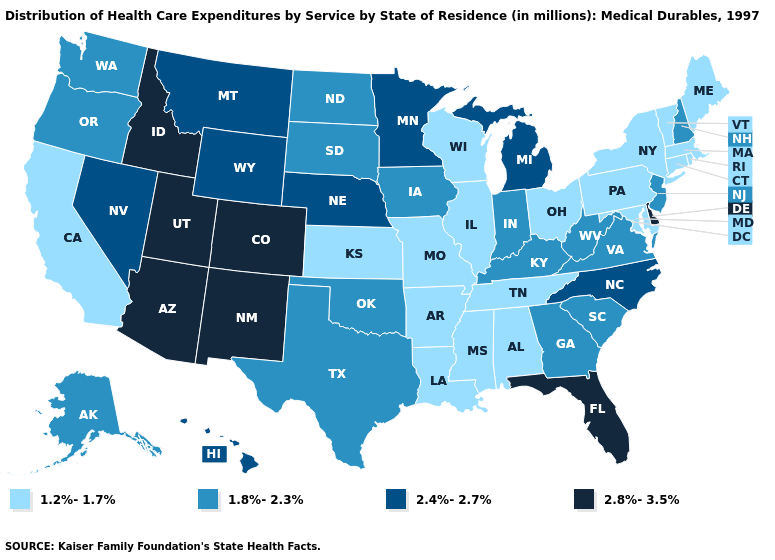What is the value of California?
Give a very brief answer. 1.2%-1.7%. What is the lowest value in the USA?
Short answer required. 1.2%-1.7%. Does Louisiana have the highest value in the South?
Give a very brief answer. No. Which states have the highest value in the USA?
Short answer required. Arizona, Colorado, Delaware, Florida, Idaho, New Mexico, Utah. What is the highest value in the USA?
Concise answer only. 2.8%-3.5%. What is the highest value in the MidWest ?
Concise answer only. 2.4%-2.7%. Does the first symbol in the legend represent the smallest category?
Write a very short answer. Yes. Name the states that have a value in the range 1.8%-2.3%?
Answer briefly. Alaska, Georgia, Indiana, Iowa, Kentucky, New Hampshire, New Jersey, North Dakota, Oklahoma, Oregon, South Carolina, South Dakota, Texas, Virginia, Washington, West Virginia. Name the states that have a value in the range 1.2%-1.7%?
Keep it brief. Alabama, Arkansas, California, Connecticut, Illinois, Kansas, Louisiana, Maine, Maryland, Massachusetts, Mississippi, Missouri, New York, Ohio, Pennsylvania, Rhode Island, Tennessee, Vermont, Wisconsin. Does the first symbol in the legend represent the smallest category?
Write a very short answer. Yes. Is the legend a continuous bar?
Short answer required. No. What is the value of South Dakota?
Give a very brief answer. 1.8%-2.3%. What is the highest value in states that border Maine?
Be succinct. 1.8%-2.3%. What is the value of Utah?
Short answer required. 2.8%-3.5%. What is the value of North Carolina?
Answer briefly. 2.4%-2.7%. 